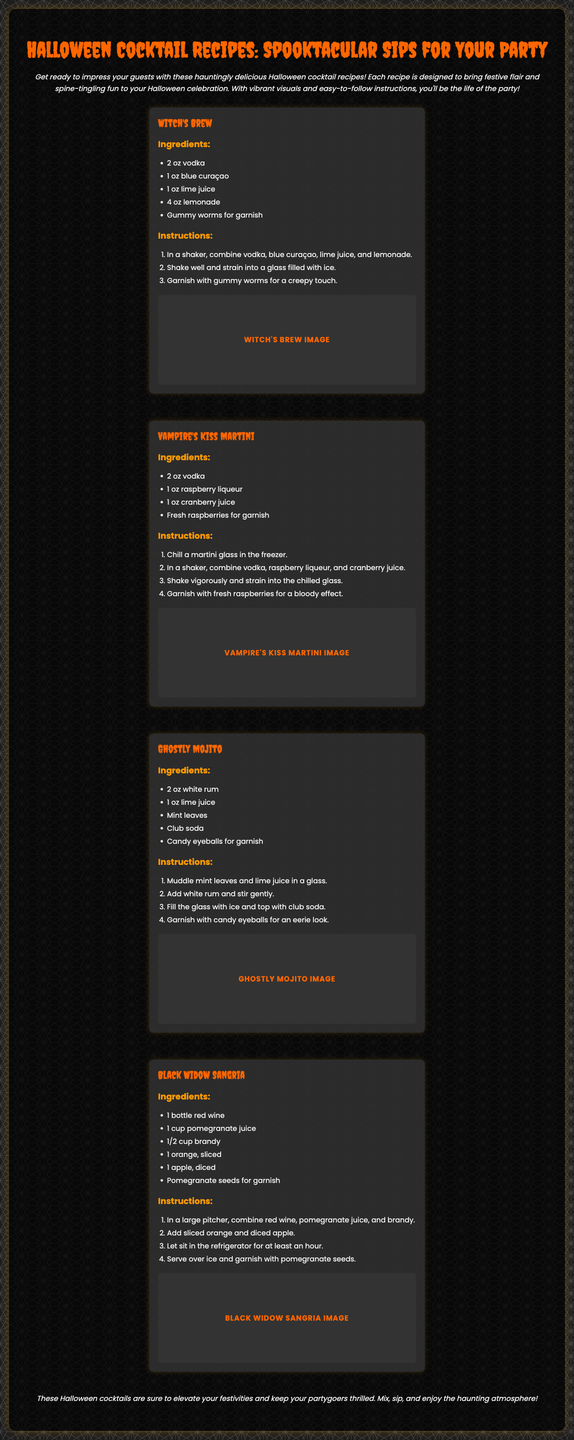What is the title of the brochure? The title is located at the top of the document.
Answer: Halloween Cocktail Recipes: Spooktacular Sips for Your Party How many cocktail recipes are featured? Count the number of cocktail sections in the document.
Answer: Four What is one ingredient in the Witch's Brew? The ingredient lists are provided under each cocktail.
Answer: Vodka What garnishes are suggested for the Vampire's Kiss Martini? The answer can be found in the ingredients section for the cocktail.
Answer: Fresh raspberries What type of glass is used for the Ghostly Mojito? The instructions for the Ghostly Mojito explain the type of glass used.
Answer: Glass Which cocktail contains pomegranate juice? This requires recalling the ingredients of the cocktails.
Answer: Black Widow Sangria What theme do the cocktails represent? The introduction section describes the overall theme.
Answer: Halloween Which cocktail involves muddling mint leaves? The instructions for the Ghostly Mojito state this process.
Answer: Ghostly Mojito In what style is the brochure written? Observing the font and layout will provide insight into the style.
Answer: Festive and spooky 